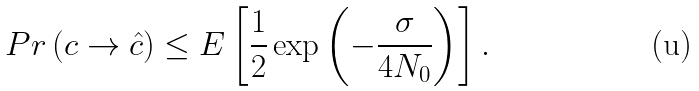Convert formula to latex. <formula><loc_0><loc_0><loc_500><loc_500>P r \left ( c \rightarrow \hat { c } \right ) \leq E \left [ \frac { 1 } { 2 } \exp \left ( - \frac { \sigma } { 4 N _ { 0 } } \right ) \right ] .</formula> 